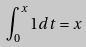<formula> <loc_0><loc_0><loc_500><loc_500>\int _ { 0 } ^ { x } 1 d t = x</formula> 